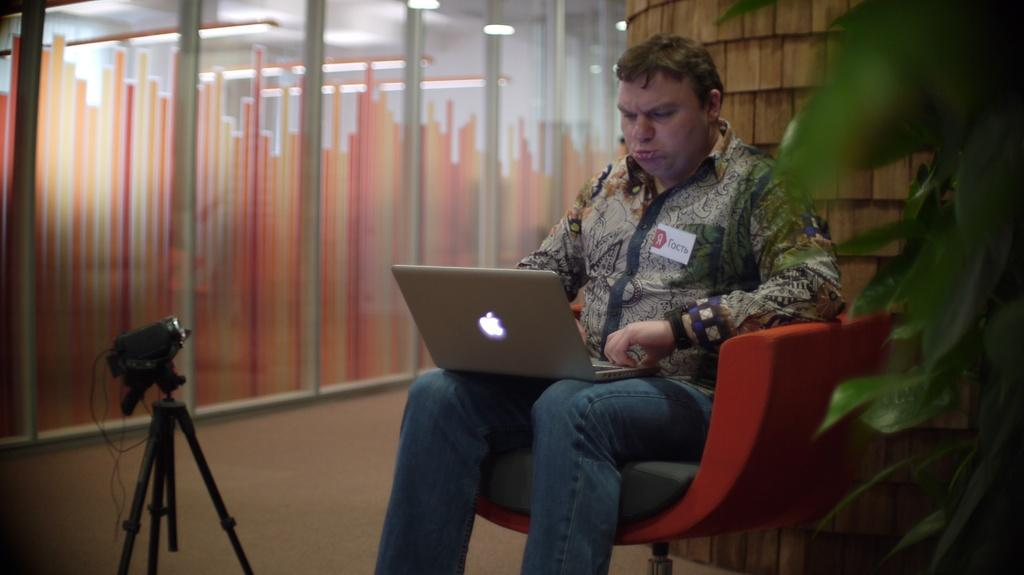What is the man in the image doing? The man is sitting on a chair and working on a laptop. Can you describe the surroundings of the man? There is a glass wall on the left side. What advertisement can be seen on the roof in the image? There is no roof or advertisement present in the image. 